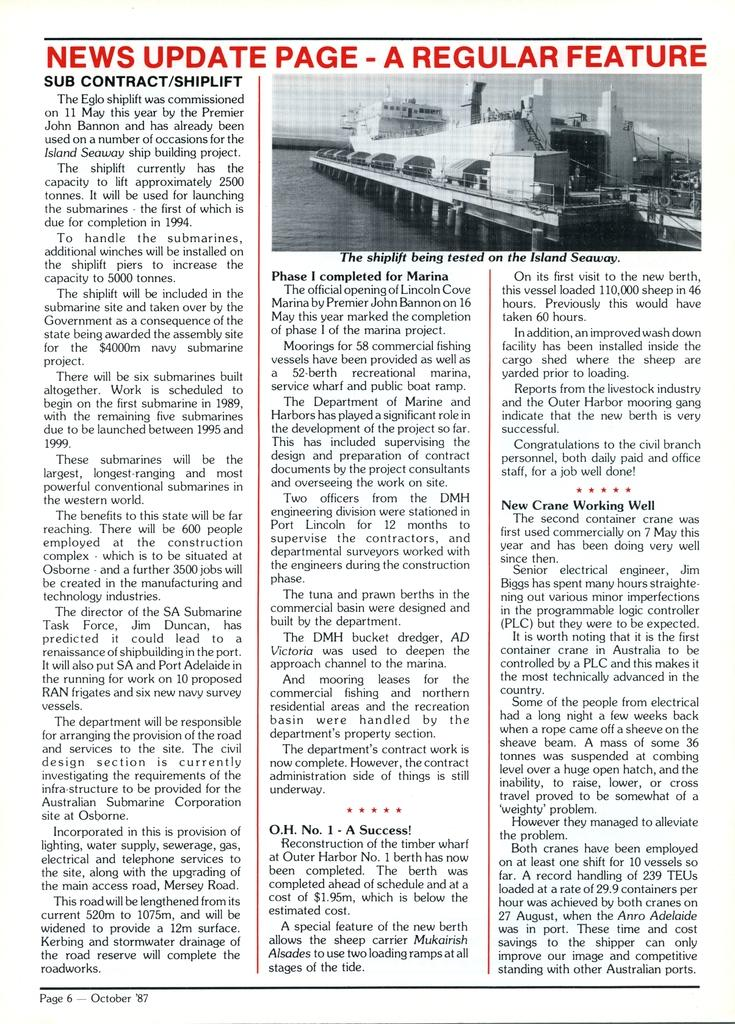<image>
Create a compact narrative representing the image presented. A news update page for a shiplift being tested on the Island Seaway. 